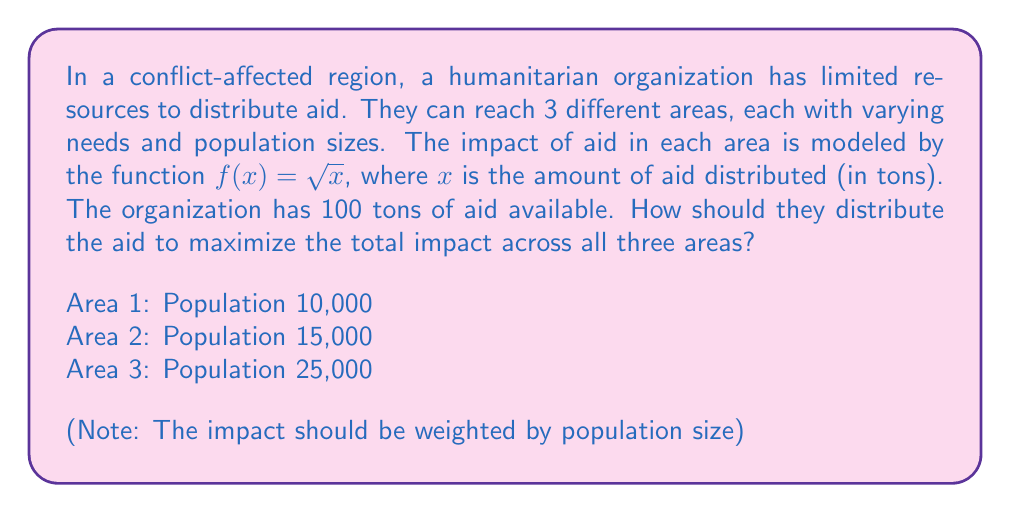Provide a solution to this math problem. 1. Let's define our variables:
   $x_1$, $x_2$, $x_3$ = amount of aid distributed to Areas 1, 2, and 3 respectively

2. Our objective function to maximize is:
   $$ F = 10000\sqrt{x_1} + 15000\sqrt{x_2} + 25000\sqrt{x_3} $$

3. Our constraint is:
   $$ x_1 + x_2 + x_3 = 100 $$

4. To solve this optimization problem, we use the method of Lagrange multipliers:
   $$ L = 10000\sqrt{x_1} + 15000\sqrt{x_2} + 25000\sqrt{x_3} - \lambda(x_1 + x_2 + x_3 - 100) $$

5. Take partial derivatives and set them equal to zero:
   $$ \frac{\partial L}{\partial x_1} = \frac{5000}{\sqrt{x_1}} - \lambda = 0 $$
   $$ \frac{\partial L}{\partial x_2} = \frac{7500}{\sqrt{x_2}} - \lambda = 0 $$
   $$ \frac{\partial L}{\partial x_3} = \frac{12500}{\sqrt{x_3}} - \lambda = 0 $$

6. From these equations, we can derive:
   $$ \frac{5000}{\sqrt{x_1}} = \frac{7500}{\sqrt{x_2}} = \frac{12500}{\sqrt{x_3}} $$

7. This implies:
   $$ x_1 : x_2 : x_3 = 5000^2 : 7500^2 : 12500^2 = 1 : 2.25 : 6.25 $$

8. Using the constraint equation:
   $$ x_1 + 2.25x_1 + 6.25x_1 = 100 $$
   $$ 9.5x_1 = 100 $$
   $$ x_1 = 10.53 $$

9. Therefore:
   $x_1 = 10.53$ tons
   $x_2 = 23.68$ tons
   $x_3 = 65.79$ tons
Answer: Area 1: 10.53 tons, Area 2: 23.68 tons, Area 3: 65.79 tons 